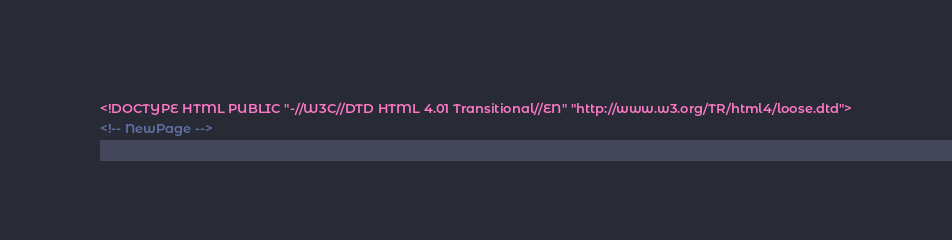<code> <loc_0><loc_0><loc_500><loc_500><_HTML_><!DOCTYPE HTML PUBLIC "-//W3C//DTD HTML 4.01 Transitional//EN" "http://www.w3.org/TR/html4/loose.dtd">
<!-- NewPage --></code> 